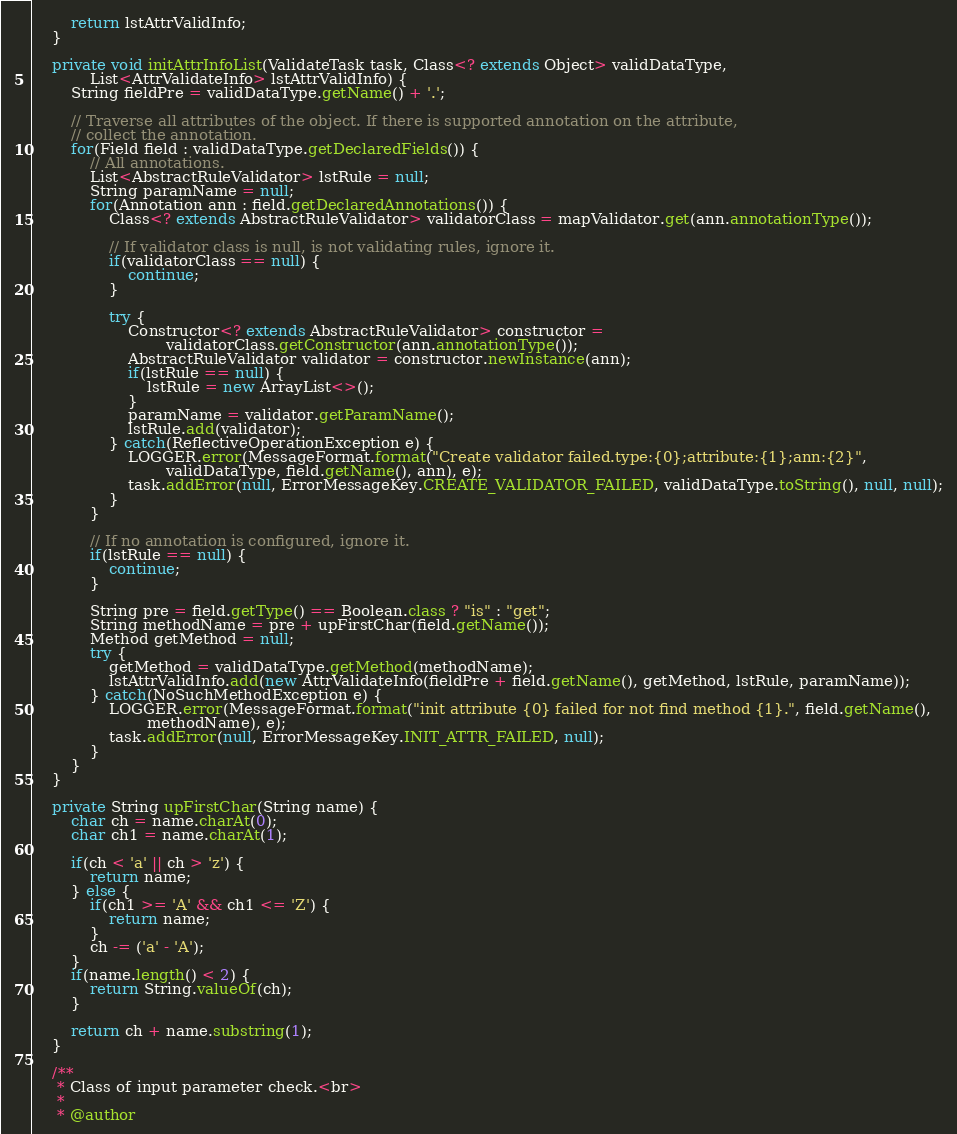<code> <loc_0><loc_0><loc_500><loc_500><_Java_>
        return lstAttrValidInfo;
    }

    private void initAttrInfoList(ValidateTask task, Class<? extends Object> validDataType,
            List<AttrValidateInfo> lstAttrValidInfo) {
        String fieldPre = validDataType.getName() + '.';

        // Traverse all attributes of the object. If there is supported annotation on the attribute,
        // collect the annotation.
        for(Field field : validDataType.getDeclaredFields()) {
            // All annotations.
            List<AbstractRuleValidator> lstRule = null;
            String paramName = null;
            for(Annotation ann : field.getDeclaredAnnotations()) {
                Class<? extends AbstractRuleValidator> validatorClass = mapValidator.get(ann.annotationType());

                // If validator class is null, is not validating rules, ignore it.
                if(validatorClass == null) {
                    continue;
                }

                try {
                    Constructor<? extends AbstractRuleValidator> constructor =
                            validatorClass.getConstructor(ann.annotationType());
                    AbstractRuleValidator validator = constructor.newInstance(ann);
                    if(lstRule == null) {
                        lstRule = new ArrayList<>();
                    }
                    paramName = validator.getParamName();
                    lstRule.add(validator);
                } catch(ReflectiveOperationException e) {
                    LOGGER.error(MessageFormat.format("Create validator failed.type:{0};attribute:{1};ann:{2}",
                            validDataType, field.getName(), ann), e);
                    task.addError(null, ErrorMessageKey.CREATE_VALIDATOR_FAILED, validDataType.toString(), null, null);
                }
            }

            // If no annotation is configured, ignore it.
            if(lstRule == null) {
                continue;
            }

            String pre = field.getType() == Boolean.class ? "is" : "get";
            String methodName = pre + upFirstChar(field.getName());
            Method getMethod = null;
            try {
                getMethod = validDataType.getMethod(methodName);
                lstAttrValidInfo.add(new AttrValidateInfo(fieldPre + field.getName(), getMethod, lstRule, paramName));
            } catch(NoSuchMethodException e) {
                LOGGER.error(MessageFormat.format("init attribute {0} failed for not find method {1}.", field.getName(),
                        methodName), e);
                task.addError(null, ErrorMessageKey.INIT_ATTR_FAILED, null);
            }
        }
    }

    private String upFirstChar(String name) {
        char ch = name.charAt(0);
        char ch1 = name.charAt(1);

        if(ch < 'a' || ch > 'z') {
            return name;
        } else {
            if(ch1 >= 'A' && ch1 <= 'Z') {
                return name;
            }
            ch -= ('a' - 'A');
        }
        if(name.length() < 2) {
            return String.valueOf(ch);
        }

        return ch + name.substring(1);
    }

    /**
     * Class of input parameter check.<br>
     * 
     * @author</code> 